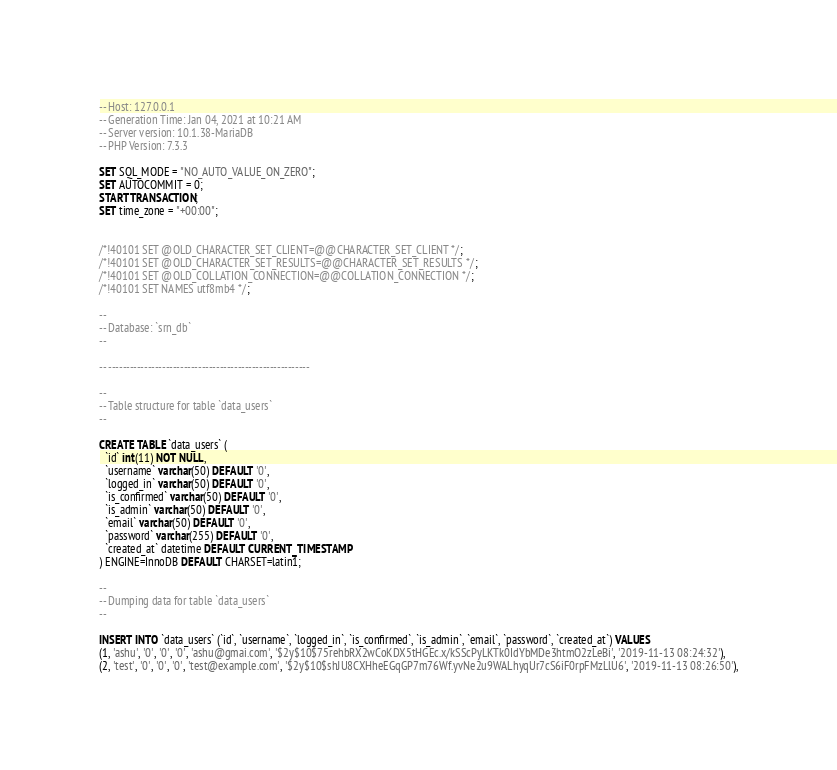<code> <loc_0><loc_0><loc_500><loc_500><_SQL_>-- Host: 127.0.0.1
-- Generation Time: Jan 04, 2021 at 10:21 AM
-- Server version: 10.1.38-MariaDB
-- PHP Version: 7.3.3

SET SQL_MODE = "NO_AUTO_VALUE_ON_ZERO";
SET AUTOCOMMIT = 0;
START TRANSACTION;
SET time_zone = "+00:00";


/*!40101 SET @OLD_CHARACTER_SET_CLIENT=@@CHARACTER_SET_CLIENT */;
/*!40101 SET @OLD_CHARACTER_SET_RESULTS=@@CHARACTER_SET_RESULTS */;
/*!40101 SET @OLD_COLLATION_CONNECTION=@@COLLATION_CONNECTION */;
/*!40101 SET NAMES utf8mb4 */;

--
-- Database: `srn_db`
--

-- --------------------------------------------------------

--
-- Table structure for table `data_users`
--

CREATE TABLE `data_users` (
  `id` int(11) NOT NULL,
  `username` varchar(50) DEFAULT '0',
  `logged_in` varchar(50) DEFAULT '0',
  `is_confirmed` varchar(50) DEFAULT '0',
  `is_admin` varchar(50) DEFAULT '0',
  `email` varchar(50) DEFAULT '0',
  `password` varchar(255) DEFAULT '0',
  `created_at` datetime DEFAULT CURRENT_TIMESTAMP
) ENGINE=InnoDB DEFAULT CHARSET=latin1;

--
-- Dumping data for table `data_users`
--

INSERT INTO `data_users` (`id`, `username`, `logged_in`, `is_confirmed`, `is_admin`, `email`, `password`, `created_at`) VALUES
(1, 'ashu', '0', '0', '0', 'ashu@gmai.com', '$2y$10$75rehbRX2wCoKDX5tHGEc.x/kSScPyLKTk0IdYbMDe3htmO2zLeBi', '2019-11-13 08:24:32'),
(2, 'test', '0', '0', '0', 'test@example.com', '$2y$10$shJU8CXHheEGqGP7m76Wf.yvNe2u9WALhyqUr7cS6iF0rpFMzLlU6', '2019-11-13 08:26:50'),</code> 